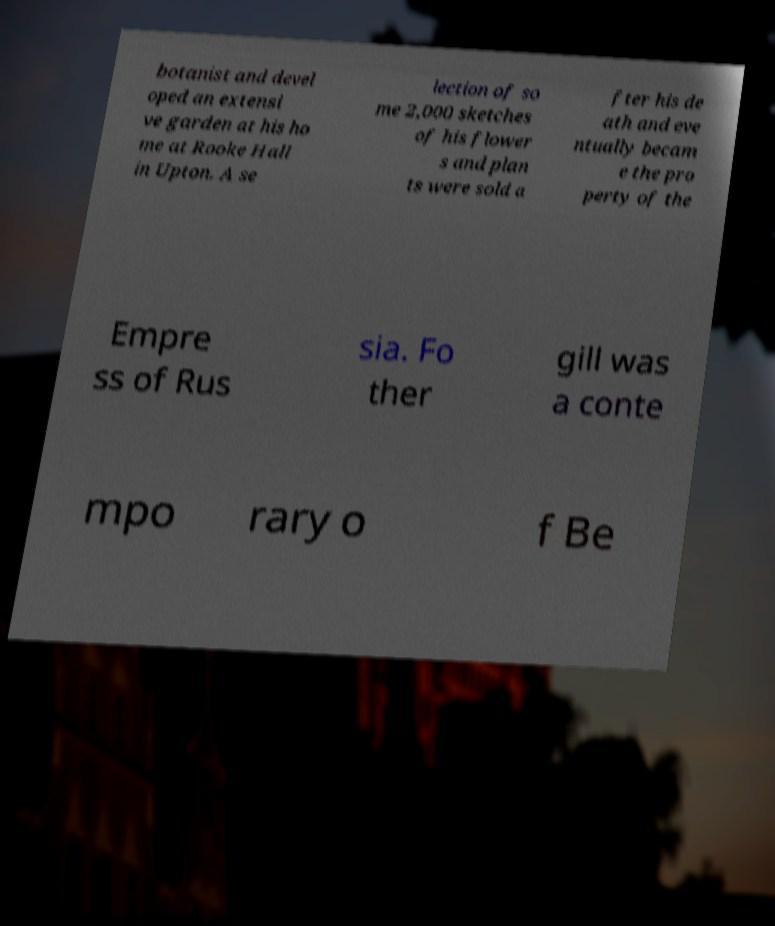Can you read and provide the text displayed in the image?This photo seems to have some interesting text. Can you extract and type it out for me? botanist and devel oped an extensi ve garden at his ho me at Rooke Hall in Upton. A se lection of so me 2,000 sketches of his flower s and plan ts were sold a fter his de ath and eve ntually becam e the pro perty of the Empre ss of Rus sia. Fo ther gill was a conte mpo rary o f Be 